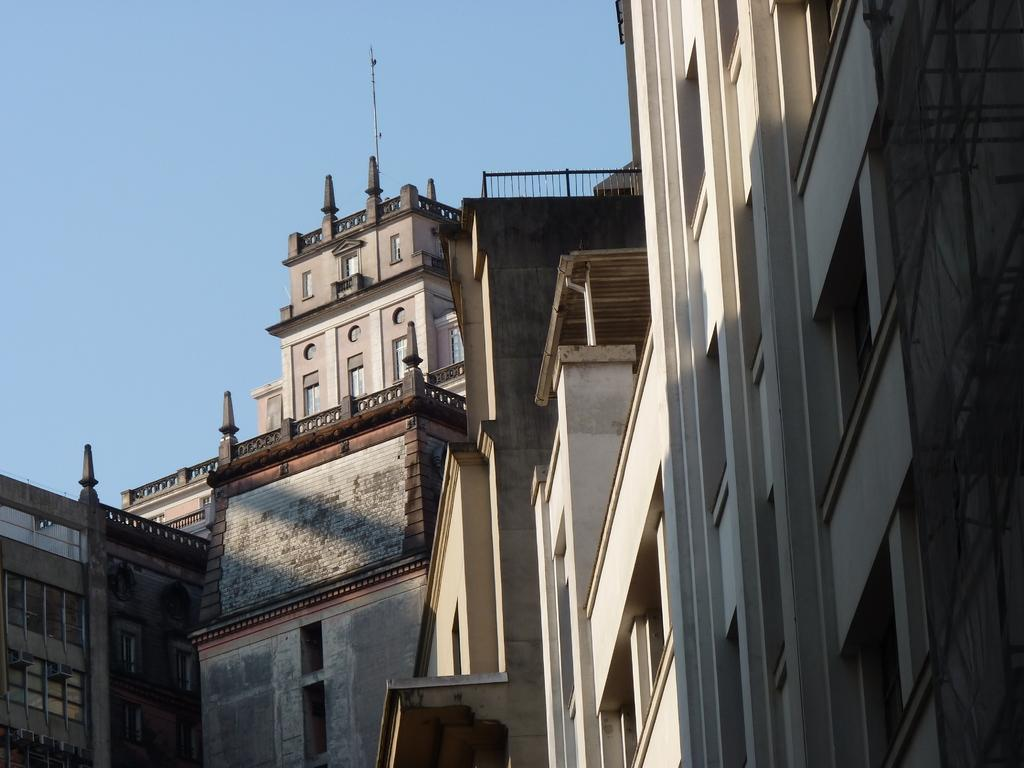What type of structures can be seen in the image? There are buildings in the image. What is visible at the top of the image? The sky is visible at the top of the image. What type of animals can be seen at the zoo in the image? There is no zoo present in the image, so it is not possible to determine what animals might be seen. 